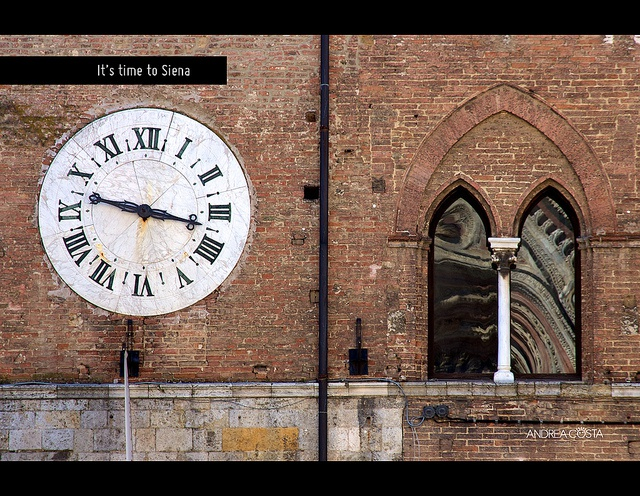Describe the objects in this image and their specific colors. I can see a clock in black, lavender, darkgray, and gray tones in this image. 